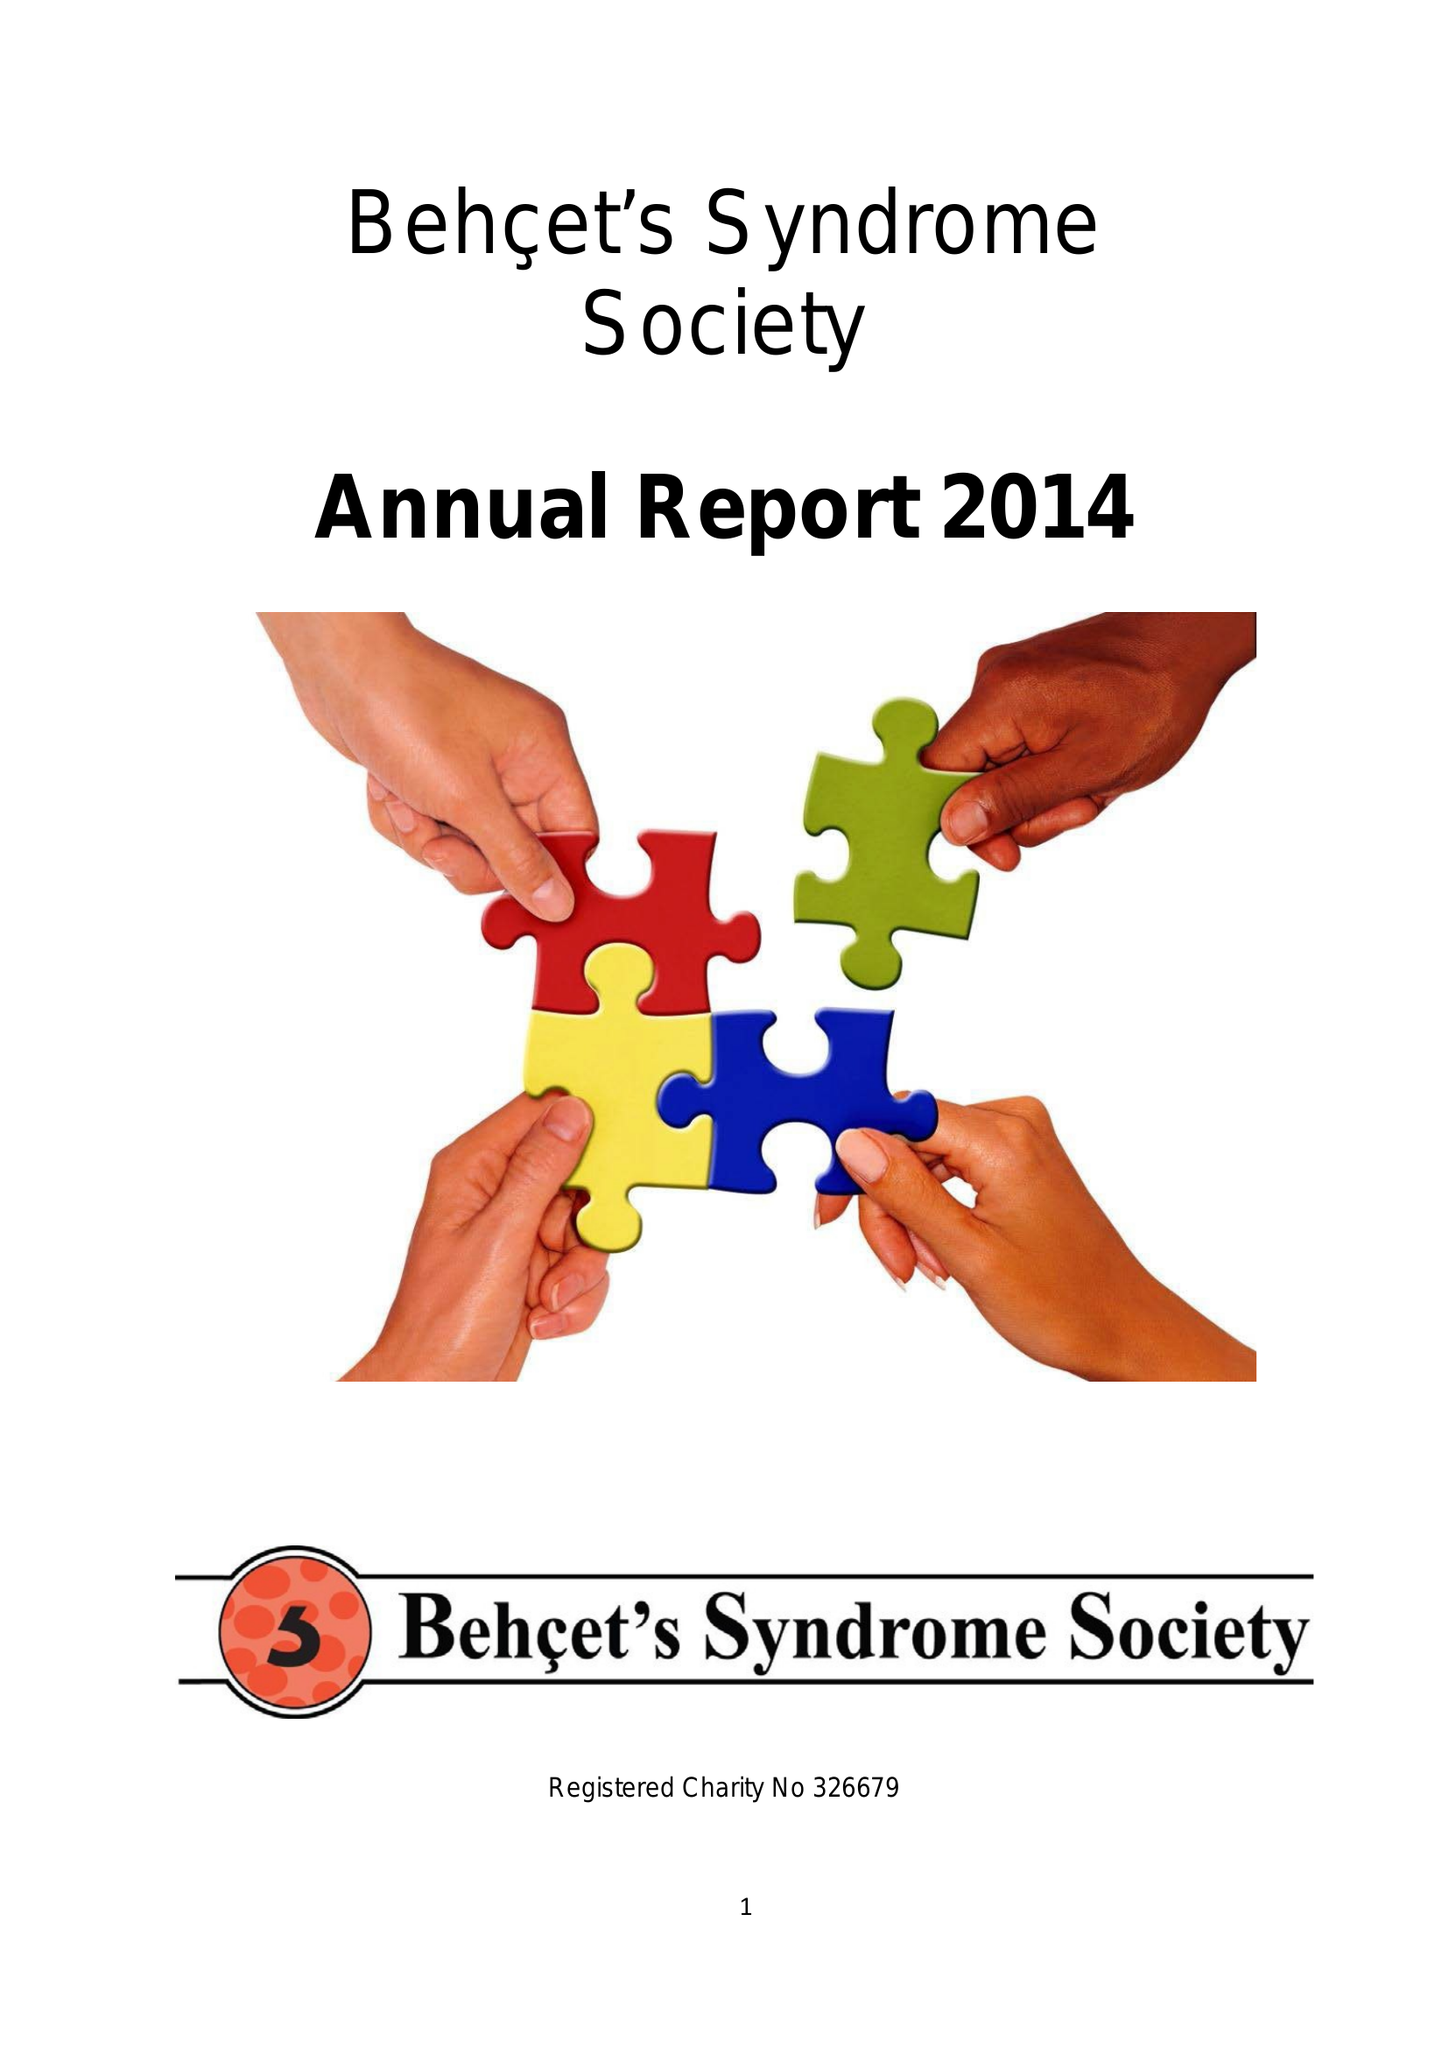What is the value for the address__post_town?
Answer the question using a single word or phrase. LONDON 